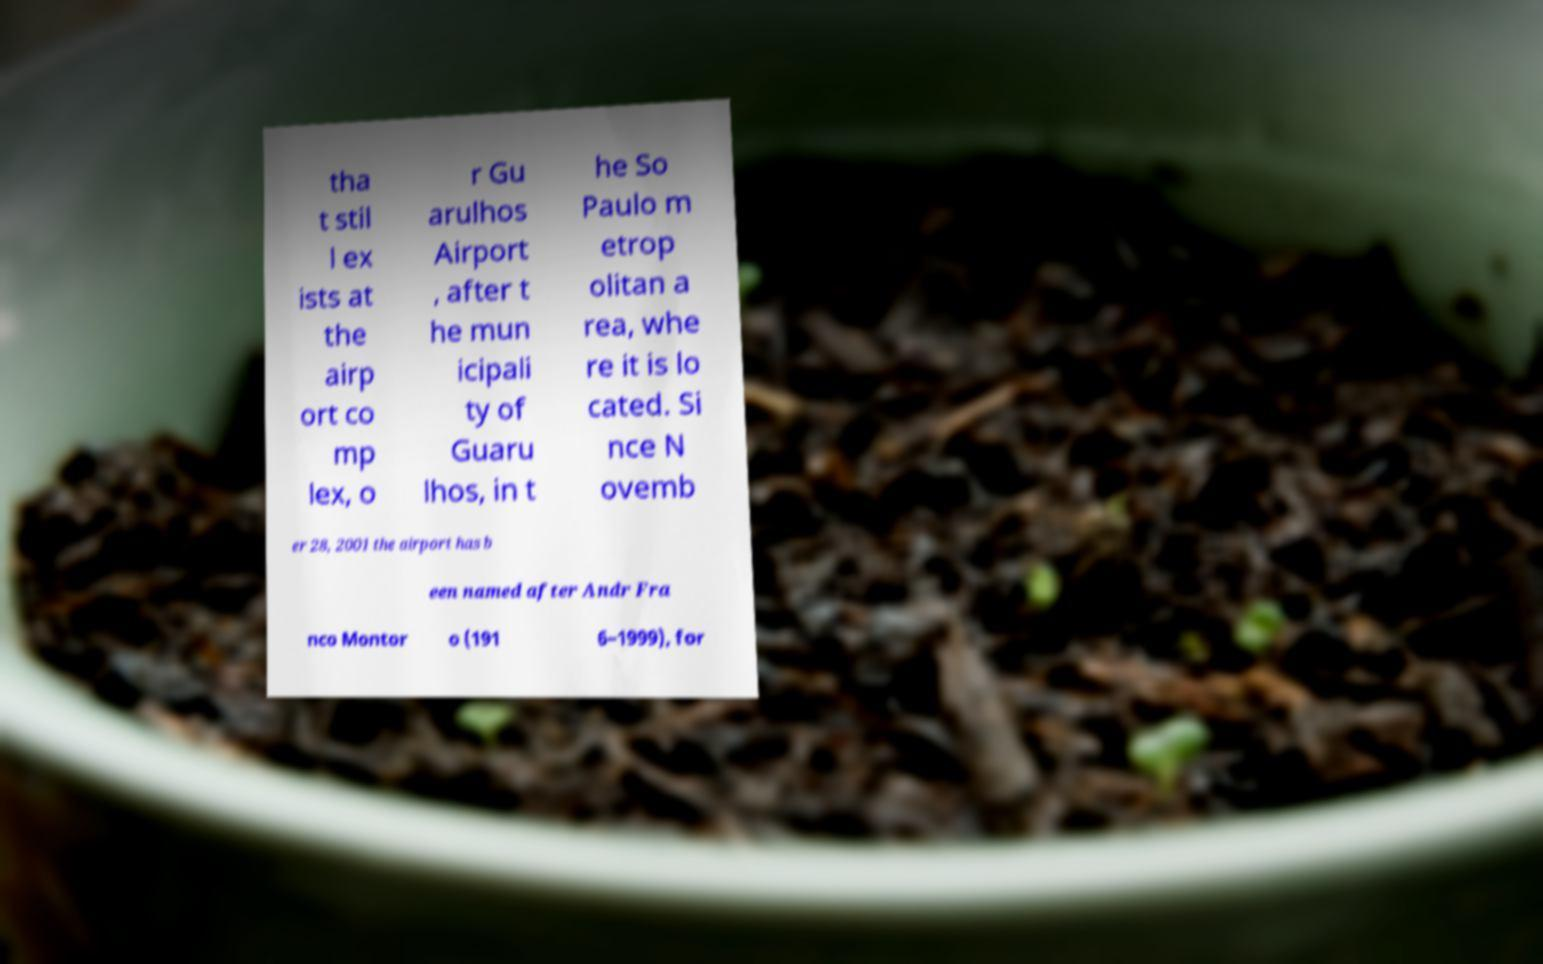Can you accurately transcribe the text from the provided image for me? tha t stil l ex ists at the airp ort co mp lex, o r Gu arulhos Airport , after t he mun icipali ty of Guaru lhos, in t he So Paulo m etrop olitan a rea, whe re it is lo cated. Si nce N ovemb er 28, 2001 the airport has b een named after Andr Fra nco Montor o (191 6–1999), for 